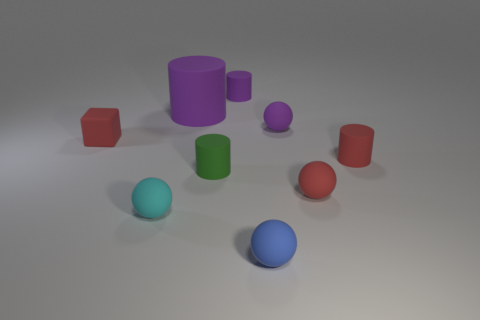Subtract all small purple matte balls. How many balls are left? 3 Subtract 2 spheres. How many spheres are left? 2 Add 1 small matte cubes. How many objects exist? 10 Subtract all cyan balls. How many balls are left? 3 Subtract all cylinders. How many objects are left? 5 Add 2 tiny red rubber blocks. How many tiny red rubber blocks exist? 3 Subtract 1 purple cylinders. How many objects are left? 8 Subtract all purple balls. Subtract all yellow cylinders. How many balls are left? 3 Subtract all purple cylinders. How many gray balls are left? 0 Subtract all rubber cubes. Subtract all blue matte spheres. How many objects are left? 7 